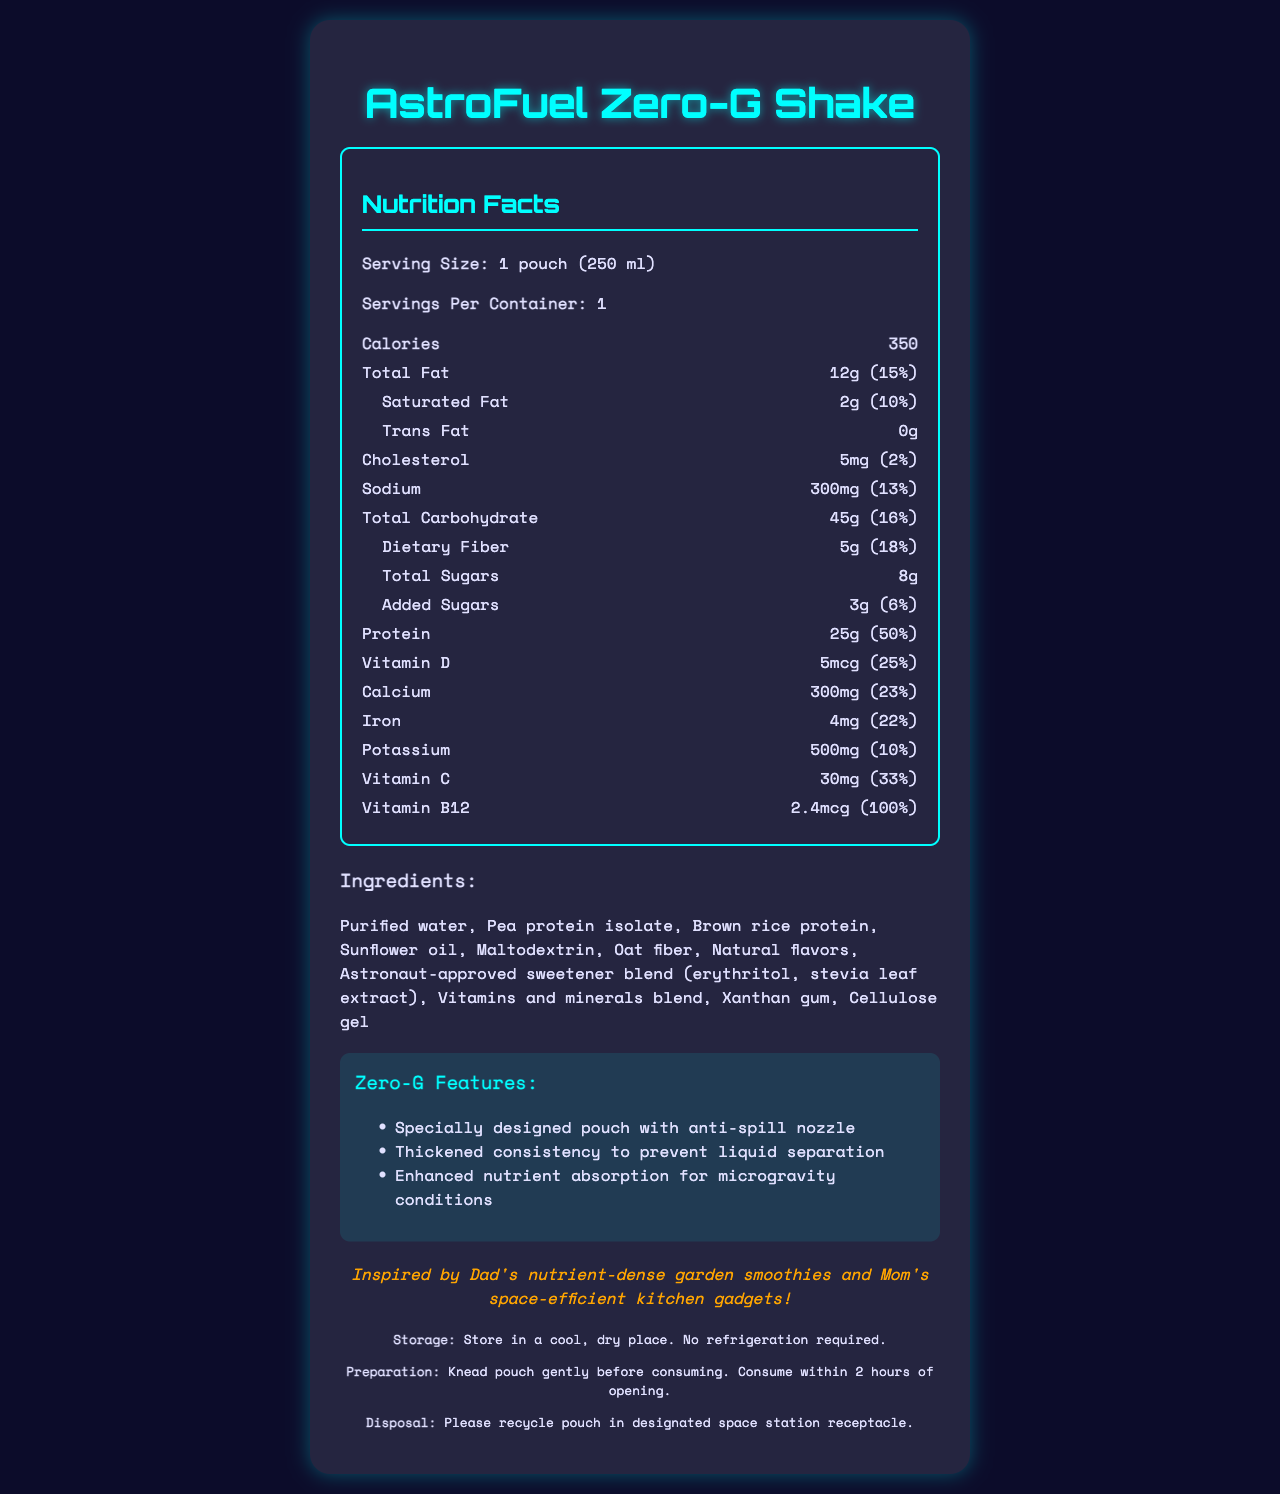what is the serving size for the AstroFuel Zero-G Shake? The serving size is clearly stated at the beginning of the nutrition facts section.
Answer: 1 pouch (250 ml) how many calories are in one serving of the AstroFuel Zero-G Shake? The nutrition facts section shows the calorie content right below the serving size information.
Answer: 350 what ingredients are listed for the AstroFuel Zero-G Shake? The ingredients list is provided in the section after the nutrition facts.
Answer: Purified water, Pea protein isolate, Brown rice protein, Sunflower oil, Maltodextrin, Oat fiber, Natural flavors, Astronaut-approved sweetener blend (erythritol, stevia leaf extract), Vitamins and minerals blend, Xanthan gum, Cellulose gel what is the daily value percentage for protein? The protein daily value percentage is listed next to the protein amount in the nutrition facts section.
Answer: 50% is there any fiber in one serving of the AstroFuel Zero-G Shake? The nutrition facts section lists 5g of dietary fiber, which is 18% of the daily value.
Answer: Yes which vitamin has the highest daily value percentage in the AstroFuel Zero-G Shake?
A. Vitamin D
B. Vitamin C
C. Vitamin B12
D. Calcium Vitamin B12 has a daily value of 100%, while Vitamin D has 25%, Vitamin C has 33%, and Calcium has 23%.
Answer: C. Vitamin B12 how much sodium is in one serving of the AstroFuel Zero-G Shake?
A. 100mg
B. 200mg
C. 300mg
D. 400mg The nutrition facts section lists the sodium content as 300mg, which is 13% of the daily value.
Answer: C. 300mg does the AstroFuel Zero-G Shake contain any allergens? The allergen information state that the product contains "None" under the allergen info section.
Answer: No summarize the main idea of the AstroFuel Zero-G Shake's nutrition facts document This summary encompasses the essential details covered in the document, capturing its main content and objective.
Answer: The document provides a comprehensive overview of the AstroFuel Zero-G Shake, including its serving size, calorie content, detailed nutritional information, ingredients, zero-gravity-friendly features, and storage and preparation instructions. Additionally, a personal note from the inventor highlights the inspiration behind the product. which feature is specifically designed for zero-gravity environments? The zero-g features section lists this as one of the features designed to accommodate zero-gravity environments.
Answer: Specially designed pouch with anti-spill nozzle what is the source of protein used in the AstroFuel Zero-G Shake? The ingredients section lists these two sources of protein.
Answer: Pea protein isolate, Brown rice protein how should the AstroFuel Zero-G Shake be prepared before consumption? The preparation instructions are provided in the footer section of the document.
Answer: Knead pouch gently before consuming. Consume within 2 hours of opening. does the product need to be refrigerated? The storage instructions state that it should be stored in a cool, dry place, and no refrigeration is required.
Answer: No what inspired the inventor to create the AstroFuel Zero-G Shake? The inventor's note at the bottom of the document mentions the inspiration behind the product.
Answer: Inspired by Dad's nutrient-dense garden smoothies and Mom's space-efficient kitchen gadgets what date was the AstroFuel Zero-G Shake first released? The document does not provide any information on the release date of the product.
Answer: Not enough information 